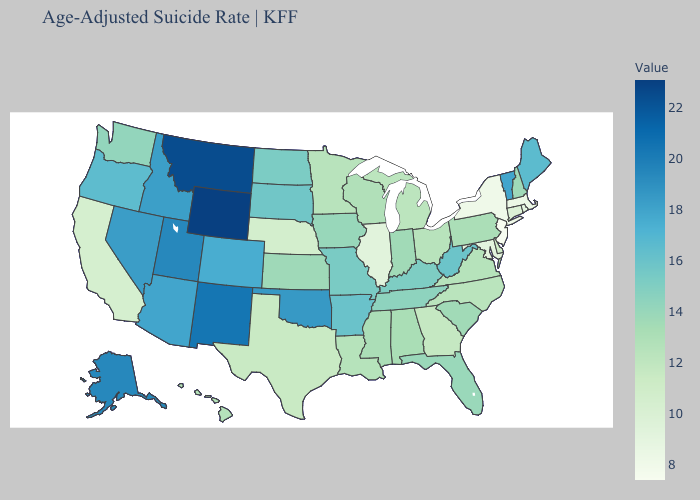Does South Dakota have the lowest value in the MidWest?
Write a very short answer. No. Is the legend a continuous bar?
Write a very short answer. Yes. Among the states that border Mississippi , does Tennessee have the highest value?
Quick response, please. No. Among the states that border Pennsylvania , which have the highest value?
Quick response, please. West Virginia. Among the states that border Pennsylvania , does West Virginia have the highest value?
Be succinct. Yes. Does Wyoming have the highest value in the West?
Answer briefly. Yes. Is the legend a continuous bar?
Keep it brief. Yes. 